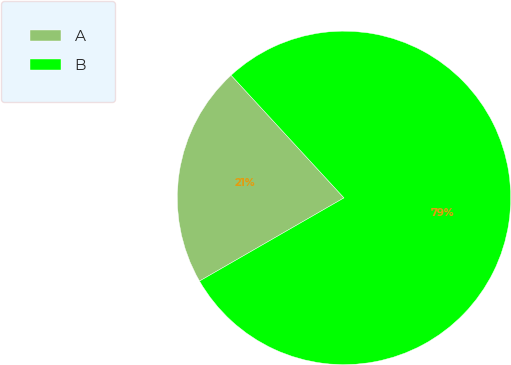Convert chart. <chart><loc_0><loc_0><loc_500><loc_500><pie_chart><fcel>A<fcel>B<nl><fcel>21.47%<fcel>78.53%<nl></chart> 